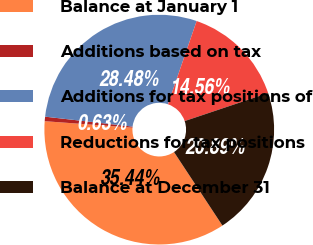Convert chart. <chart><loc_0><loc_0><loc_500><loc_500><pie_chart><fcel>Balance at January 1<fcel>Additions based on tax<fcel>Additions for tax positions of<fcel>Reductions for tax positions<fcel>Balance at December 31<nl><fcel>35.44%<fcel>0.63%<fcel>28.48%<fcel>14.56%<fcel>20.89%<nl></chart> 